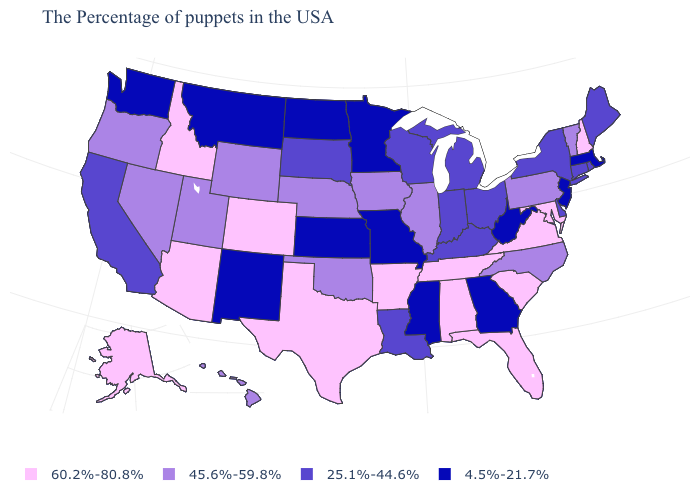What is the value of Idaho?
Give a very brief answer. 60.2%-80.8%. Name the states that have a value in the range 4.5%-21.7%?
Short answer required. Massachusetts, New Jersey, West Virginia, Georgia, Mississippi, Missouri, Minnesota, Kansas, North Dakota, New Mexico, Montana, Washington. What is the value of New York?
Short answer required. 25.1%-44.6%. Does Indiana have a higher value than Nebraska?
Short answer required. No. Does the map have missing data?
Answer briefly. No. What is the value of South Carolina?
Write a very short answer. 60.2%-80.8%. Name the states that have a value in the range 45.6%-59.8%?
Concise answer only. Vermont, Pennsylvania, North Carolina, Illinois, Iowa, Nebraska, Oklahoma, Wyoming, Utah, Nevada, Oregon, Hawaii. What is the value of Oregon?
Quick response, please. 45.6%-59.8%. Does Virginia have the highest value in the South?
Write a very short answer. Yes. What is the value of South Carolina?
Keep it brief. 60.2%-80.8%. Name the states that have a value in the range 4.5%-21.7%?
Be succinct. Massachusetts, New Jersey, West Virginia, Georgia, Mississippi, Missouri, Minnesota, Kansas, North Dakota, New Mexico, Montana, Washington. Name the states that have a value in the range 60.2%-80.8%?
Keep it brief. New Hampshire, Maryland, Virginia, South Carolina, Florida, Alabama, Tennessee, Arkansas, Texas, Colorado, Arizona, Idaho, Alaska. What is the value of Mississippi?
Be succinct. 4.5%-21.7%. 